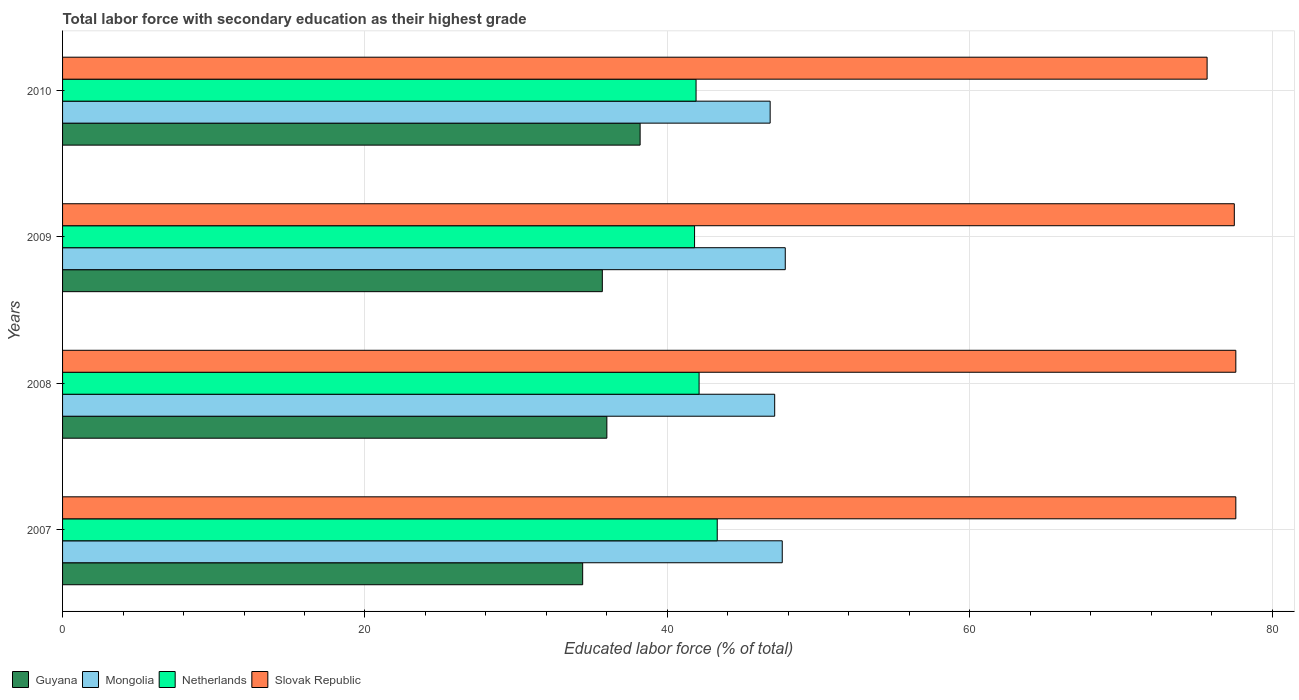How many different coloured bars are there?
Your answer should be compact. 4. How many bars are there on the 1st tick from the bottom?
Ensure brevity in your answer.  4. In how many cases, is the number of bars for a given year not equal to the number of legend labels?
Provide a succinct answer. 0. What is the percentage of total labor force with primary education in Guyana in 2009?
Your answer should be very brief. 35.7. Across all years, what is the maximum percentage of total labor force with primary education in Slovak Republic?
Offer a terse response. 77.6. Across all years, what is the minimum percentage of total labor force with primary education in Mongolia?
Your answer should be very brief. 46.8. In which year was the percentage of total labor force with primary education in Guyana minimum?
Ensure brevity in your answer.  2007. What is the total percentage of total labor force with primary education in Guyana in the graph?
Provide a succinct answer. 144.3. What is the difference between the percentage of total labor force with primary education in Mongolia in 2008 and that in 2010?
Offer a terse response. 0.3. What is the difference between the percentage of total labor force with primary education in Slovak Republic in 2009 and the percentage of total labor force with primary education in Guyana in 2007?
Make the answer very short. 43.1. What is the average percentage of total labor force with primary education in Mongolia per year?
Give a very brief answer. 47.32. In the year 2010, what is the difference between the percentage of total labor force with primary education in Mongolia and percentage of total labor force with primary education in Guyana?
Give a very brief answer. 8.6. What is the ratio of the percentage of total labor force with primary education in Netherlands in 2007 to that in 2008?
Your answer should be compact. 1.03. Is the difference between the percentage of total labor force with primary education in Mongolia in 2007 and 2008 greater than the difference between the percentage of total labor force with primary education in Guyana in 2007 and 2008?
Ensure brevity in your answer.  Yes. What is the difference between the highest and the second highest percentage of total labor force with primary education in Guyana?
Make the answer very short. 2.2. In how many years, is the percentage of total labor force with primary education in Slovak Republic greater than the average percentage of total labor force with primary education in Slovak Republic taken over all years?
Provide a succinct answer. 3. What does the 3rd bar from the top in 2010 represents?
Your answer should be compact. Mongolia. What does the 4th bar from the bottom in 2010 represents?
Offer a very short reply. Slovak Republic. Is it the case that in every year, the sum of the percentage of total labor force with primary education in Slovak Republic and percentage of total labor force with primary education in Netherlands is greater than the percentage of total labor force with primary education in Guyana?
Provide a short and direct response. Yes. How many years are there in the graph?
Your answer should be compact. 4. Does the graph contain grids?
Offer a very short reply. Yes. Where does the legend appear in the graph?
Your response must be concise. Bottom left. How many legend labels are there?
Give a very brief answer. 4. How are the legend labels stacked?
Offer a terse response. Horizontal. What is the title of the graph?
Offer a very short reply. Total labor force with secondary education as their highest grade. What is the label or title of the X-axis?
Provide a succinct answer. Educated labor force (% of total). What is the label or title of the Y-axis?
Make the answer very short. Years. What is the Educated labor force (% of total) of Guyana in 2007?
Offer a very short reply. 34.4. What is the Educated labor force (% of total) in Mongolia in 2007?
Provide a succinct answer. 47.6. What is the Educated labor force (% of total) in Netherlands in 2007?
Offer a very short reply. 43.3. What is the Educated labor force (% of total) in Slovak Republic in 2007?
Offer a very short reply. 77.6. What is the Educated labor force (% of total) of Guyana in 2008?
Keep it short and to the point. 36. What is the Educated labor force (% of total) in Mongolia in 2008?
Your answer should be very brief. 47.1. What is the Educated labor force (% of total) in Netherlands in 2008?
Your answer should be compact. 42.1. What is the Educated labor force (% of total) in Slovak Republic in 2008?
Make the answer very short. 77.6. What is the Educated labor force (% of total) of Guyana in 2009?
Offer a very short reply. 35.7. What is the Educated labor force (% of total) in Mongolia in 2009?
Your answer should be very brief. 47.8. What is the Educated labor force (% of total) in Netherlands in 2009?
Offer a terse response. 41.8. What is the Educated labor force (% of total) of Slovak Republic in 2009?
Offer a terse response. 77.5. What is the Educated labor force (% of total) in Guyana in 2010?
Ensure brevity in your answer.  38.2. What is the Educated labor force (% of total) in Mongolia in 2010?
Provide a succinct answer. 46.8. What is the Educated labor force (% of total) of Netherlands in 2010?
Your answer should be very brief. 41.9. What is the Educated labor force (% of total) of Slovak Republic in 2010?
Make the answer very short. 75.7. Across all years, what is the maximum Educated labor force (% of total) of Guyana?
Provide a short and direct response. 38.2. Across all years, what is the maximum Educated labor force (% of total) of Mongolia?
Keep it short and to the point. 47.8. Across all years, what is the maximum Educated labor force (% of total) of Netherlands?
Provide a succinct answer. 43.3. Across all years, what is the maximum Educated labor force (% of total) of Slovak Republic?
Offer a terse response. 77.6. Across all years, what is the minimum Educated labor force (% of total) of Guyana?
Make the answer very short. 34.4. Across all years, what is the minimum Educated labor force (% of total) of Mongolia?
Your response must be concise. 46.8. Across all years, what is the minimum Educated labor force (% of total) in Netherlands?
Your response must be concise. 41.8. Across all years, what is the minimum Educated labor force (% of total) in Slovak Republic?
Ensure brevity in your answer.  75.7. What is the total Educated labor force (% of total) of Guyana in the graph?
Keep it short and to the point. 144.3. What is the total Educated labor force (% of total) in Mongolia in the graph?
Offer a very short reply. 189.3. What is the total Educated labor force (% of total) in Netherlands in the graph?
Your response must be concise. 169.1. What is the total Educated labor force (% of total) in Slovak Republic in the graph?
Provide a short and direct response. 308.4. What is the difference between the Educated labor force (% of total) of Mongolia in 2007 and that in 2008?
Your answer should be compact. 0.5. What is the difference between the Educated labor force (% of total) of Netherlands in 2007 and that in 2008?
Make the answer very short. 1.2. What is the difference between the Educated labor force (% of total) in Slovak Republic in 2007 and that in 2008?
Make the answer very short. 0. What is the difference between the Educated labor force (% of total) of Guyana in 2007 and that in 2009?
Make the answer very short. -1.3. What is the difference between the Educated labor force (% of total) in Mongolia in 2007 and that in 2009?
Keep it short and to the point. -0.2. What is the difference between the Educated labor force (% of total) in Guyana in 2007 and that in 2010?
Your response must be concise. -3.8. What is the difference between the Educated labor force (% of total) in Netherlands in 2007 and that in 2010?
Give a very brief answer. 1.4. What is the difference between the Educated labor force (% of total) in Mongolia in 2008 and that in 2009?
Provide a short and direct response. -0.7. What is the difference between the Educated labor force (% of total) of Netherlands in 2008 and that in 2009?
Make the answer very short. 0.3. What is the difference between the Educated labor force (% of total) of Guyana in 2008 and that in 2010?
Offer a terse response. -2.2. What is the difference between the Educated labor force (% of total) in Netherlands in 2008 and that in 2010?
Give a very brief answer. 0.2. What is the difference between the Educated labor force (% of total) of Slovak Republic in 2008 and that in 2010?
Your answer should be compact. 1.9. What is the difference between the Educated labor force (% of total) in Mongolia in 2009 and that in 2010?
Your answer should be very brief. 1. What is the difference between the Educated labor force (% of total) of Slovak Republic in 2009 and that in 2010?
Your answer should be compact. 1.8. What is the difference between the Educated labor force (% of total) of Guyana in 2007 and the Educated labor force (% of total) of Mongolia in 2008?
Your response must be concise. -12.7. What is the difference between the Educated labor force (% of total) of Guyana in 2007 and the Educated labor force (% of total) of Netherlands in 2008?
Provide a short and direct response. -7.7. What is the difference between the Educated labor force (% of total) in Guyana in 2007 and the Educated labor force (% of total) in Slovak Republic in 2008?
Provide a succinct answer. -43.2. What is the difference between the Educated labor force (% of total) in Netherlands in 2007 and the Educated labor force (% of total) in Slovak Republic in 2008?
Your response must be concise. -34.3. What is the difference between the Educated labor force (% of total) of Guyana in 2007 and the Educated labor force (% of total) of Mongolia in 2009?
Provide a short and direct response. -13.4. What is the difference between the Educated labor force (% of total) of Guyana in 2007 and the Educated labor force (% of total) of Netherlands in 2009?
Provide a short and direct response. -7.4. What is the difference between the Educated labor force (% of total) of Guyana in 2007 and the Educated labor force (% of total) of Slovak Republic in 2009?
Make the answer very short. -43.1. What is the difference between the Educated labor force (% of total) in Mongolia in 2007 and the Educated labor force (% of total) in Netherlands in 2009?
Your answer should be compact. 5.8. What is the difference between the Educated labor force (% of total) of Mongolia in 2007 and the Educated labor force (% of total) of Slovak Republic in 2009?
Keep it short and to the point. -29.9. What is the difference between the Educated labor force (% of total) of Netherlands in 2007 and the Educated labor force (% of total) of Slovak Republic in 2009?
Offer a very short reply. -34.2. What is the difference between the Educated labor force (% of total) in Guyana in 2007 and the Educated labor force (% of total) in Mongolia in 2010?
Your answer should be very brief. -12.4. What is the difference between the Educated labor force (% of total) in Guyana in 2007 and the Educated labor force (% of total) in Netherlands in 2010?
Your answer should be very brief. -7.5. What is the difference between the Educated labor force (% of total) of Guyana in 2007 and the Educated labor force (% of total) of Slovak Republic in 2010?
Give a very brief answer. -41.3. What is the difference between the Educated labor force (% of total) in Mongolia in 2007 and the Educated labor force (% of total) in Netherlands in 2010?
Your answer should be very brief. 5.7. What is the difference between the Educated labor force (% of total) of Mongolia in 2007 and the Educated labor force (% of total) of Slovak Republic in 2010?
Your response must be concise. -28.1. What is the difference between the Educated labor force (% of total) of Netherlands in 2007 and the Educated labor force (% of total) of Slovak Republic in 2010?
Provide a short and direct response. -32.4. What is the difference between the Educated labor force (% of total) of Guyana in 2008 and the Educated labor force (% of total) of Slovak Republic in 2009?
Your answer should be very brief. -41.5. What is the difference between the Educated labor force (% of total) in Mongolia in 2008 and the Educated labor force (% of total) in Slovak Republic in 2009?
Give a very brief answer. -30.4. What is the difference between the Educated labor force (% of total) in Netherlands in 2008 and the Educated labor force (% of total) in Slovak Republic in 2009?
Offer a very short reply. -35.4. What is the difference between the Educated labor force (% of total) in Guyana in 2008 and the Educated labor force (% of total) in Netherlands in 2010?
Your answer should be compact. -5.9. What is the difference between the Educated labor force (% of total) in Guyana in 2008 and the Educated labor force (% of total) in Slovak Republic in 2010?
Your answer should be very brief. -39.7. What is the difference between the Educated labor force (% of total) in Mongolia in 2008 and the Educated labor force (% of total) in Netherlands in 2010?
Your answer should be very brief. 5.2. What is the difference between the Educated labor force (% of total) in Mongolia in 2008 and the Educated labor force (% of total) in Slovak Republic in 2010?
Give a very brief answer. -28.6. What is the difference between the Educated labor force (% of total) of Netherlands in 2008 and the Educated labor force (% of total) of Slovak Republic in 2010?
Keep it short and to the point. -33.6. What is the difference between the Educated labor force (% of total) in Guyana in 2009 and the Educated labor force (% of total) in Mongolia in 2010?
Keep it short and to the point. -11.1. What is the difference between the Educated labor force (% of total) in Guyana in 2009 and the Educated labor force (% of total) in Slovak Republic in 2010?
Your answer should be compact. -40. What is the difference between the Educated labor force (% of total) in Mongolia in 2009 and the Educated labor force (% of total) in Netherlands in 2010?
Provide a short and direct response. 5.9. What is the difference between the Educated labor force (% of total) in Mongolia in 2009 and the Educated labor force (% of total) in Slovak Republic in 2010?
Provide a succinct answer. -27.9. What is the difference between the Educated labor force (% of total) of Netherlands in 2009 and the Educated labor force (% of total) of Slovak Republic in 2010?
Offer a terse response. -33.9. What is the average Educated labor force (% of total) in Guyana per year?
Provide a succinct answer. 36.08. What is the average Educated labor force (% of total) in Mongolia per year?
Keep it short and to the point. 47.33. What is the average Educated labor force (% of total) in Netherlands per year?
Your response must be concise. 42.27. What is the average Educated labor force (% of total) in Slovak Republic per year?
Ensure brevity in your answer.  77.1. In the year 2007, what is the difference between the Educated labor force (% of total) of Guyana and Educated labor force (% of total) of Slovak Republic?
Your answer should be compact. -43.2. In the year 2007, what is the difference between the Educated labor force (% of total) in Mongolia and Educated labor force (% of total) in Slovak Republic?
Ensure brevity in your answer.  -30. In the year 2007, what is the difference between the Educated labor force (% of total) in Netherlands and Educated labor force (% of total) in Slovak Republic?
Provide a succinct answer. -34.3. In the year 2008, what is the difference between the Educated labor force (% of total) in Guyana and Educated labor force (% of total) in Slovak Republic?
Ensure brevity in your answer.  -41.6. In the year 2008, what is the difference between the Educated labor force (% of total) of Mongolia and Educated labor force (% of total) of Netherlands?
Give a very brief answer. 5. In the year 2008, what is the difference between the Educated labor force (% of total) of Mongolia and Educated labor force (% of total) of Slovak Republic?
Provide a short and direct response. -30.5. In the year 2008, what is the difference between the Educated labor force (% of total) of Netherlands and Educated labor force (% of total) of Slovak Republic?
Your answer should be very brief. -35.5. In the year 2009, what is the difference between the Educated labor force (% of total) in Guyana and Educated labor force (% of total) in Slovak Republic?
Provide a short and direct response. -41.8. In the year 2009, what is the difference between the Educated labor force (% of total) of Mongolia and Educated labor force (% of total) of Slovak Republic?
Ensure brevity in your answer.  -29.7. In the year 2009, what is the difference between the Educated labor force (% of total) in Netherlands and Educated labor force (% of total) in Slovak Republic?
Your answer should be very brief. -35.7. In the year 2010, what is the difference between the Educated labor force (% of total) in Guyana and Educated labor force (% of total) in Netherlands?
Ensure brevity in your answer.  -3.7. In the year 2010, what is the difference between the Educated labor force (% of total) in Guyana and Educated labor force (% of total) in Slovak Republic?
Your response must be concise. -37.5. In the year 2010, what is the difference between the Educated labor force (% of total) of Mongolia and Educated labor force (% of total) of Netherlands?
Provide a succinct answer. 4.9. In the year 2010, what is the difference between the Educated labor force (% of total) of Mongolia and Educated labor force (% of total) of Slovak Republic?
Give a very brief answer. -28.9. In the year 2010, what is the difference between the Educated labor force (% of total) in Netherlands and Educated labor force (% of total) in Slovak Republic?
Your answer should be very brief. -33.8. What is the ratio of the Educated labor force (% of total) of Guyana in 2007 to that in 2008?
Provide a short and direct response. 0.96. What is the ratio of the Educated labor force (% of total) of Mongolia in 2007 to that in 2008?
Offer a terse response. 1.01. What is the ratio of the Educated labor force (% of total) of Netherlands in 2007 to that in 2008?
Make the answer very short. 1.03. What is the ratio of the Educated labor force (% of total) of Guyana in 2007 to that in 2009?
Provide a succinct answer. 0.96. What is the ratio of the Educated labor force (% of total) in Mongolia in 2007 to that in 2009?
Your answer should be compact. 1. What is the ratio of the Educated labor force (% of total) in Netherlands in 2007 to that in 2009?
Your answer should be compact. 1.04. What is the ratio of the Educated labor force (% of total) of Slovak Republic in 2007 to that in 2009?
Make the answer very short. 1. What is the ratio of the Educated labor force (% of total) in Guyana in 2007 to that in 2010?
Ensure brevity in your answer.  0.9. What is the ratio of the Educated labor force (% of total) of Mongolia in 2007 to that in 2010?
Your answer should be very brief. 1.02. What is the ratio of the Educated labor force (% of total) in Netherlands in 2007 to that in 2010?
Your answer should be compact. 1.03. What is the ratio of the Educated labor force (% of total) in Slovak Republic in 2007 to that in 2010?
Ensure brevity in your answer.  1.03. What is the ratio of the Educated labor force (% of total) of Guyana in 2008 to that in 2009?
Your answer should be compact. 1.01. What is the ratio of the Educated labor force (% of total) in Mongolia in 2008 to that in 2009?
Your answer should be very brief. 0.99. What is the ratio of the Educated labor force (% of total) in Slovak Republic in 2008 to that in 2009?
Offer a very short reply. 1. What is the ratio of the Educated labor force (% of total) of Guyana in 2008 to that in 2010?
Offer a terse response. 0.94. What is the ratio of the Educated labor force (% of total) of Mongolia in 2008 to that in 2010?
Offer a very short reply. 1.01. What is the ratio of the Educated labor force (% of total) in Slovak Republic in 2008 to that in 2010?
Provide a short and direct response. 1.03. What is the ratio of the Educated labor force (% of total) in Guyana in 2009 to that in 2010?
Your answer should be compact. 0.93. What is the ratio of the Educated labor force (% of total) in Mongolia in 2009 to that in 2010?
Ensure brevity in your answer.  1.02. What is the ratio of the Educated labor force (% of total) of Slovak Republic in 2009 to that in 2010?
Ensure brevity in your answer.  1.02. What is the difference between the highest and the second highest Educated labor force (% of total) of Mongolia?
Offer a terse response. 0.2. What is the difference between the highest and the second highest Educated labor force (% of total) of Netherlands?
Offer a very short reply. 1.2. What is the difference between the highest and the second highest Educated labor force (% of total) of Slovak Republic?
Your response must be concise. 0. What is the difference between the highest and the lowest Educated labor force (% of total) of Netherlands?
Ensure brevity in your answer.  1.5. 